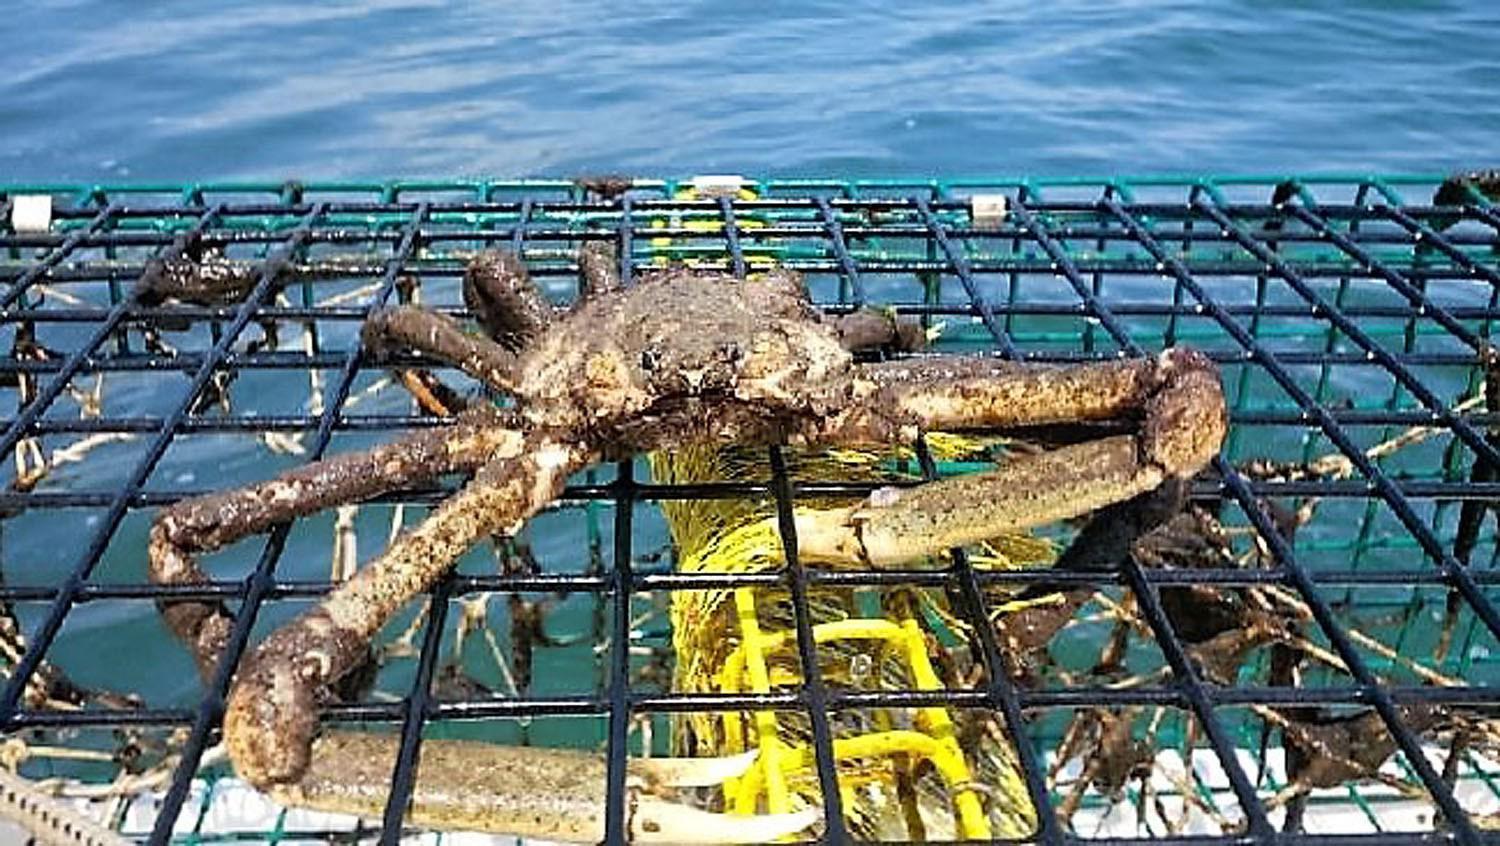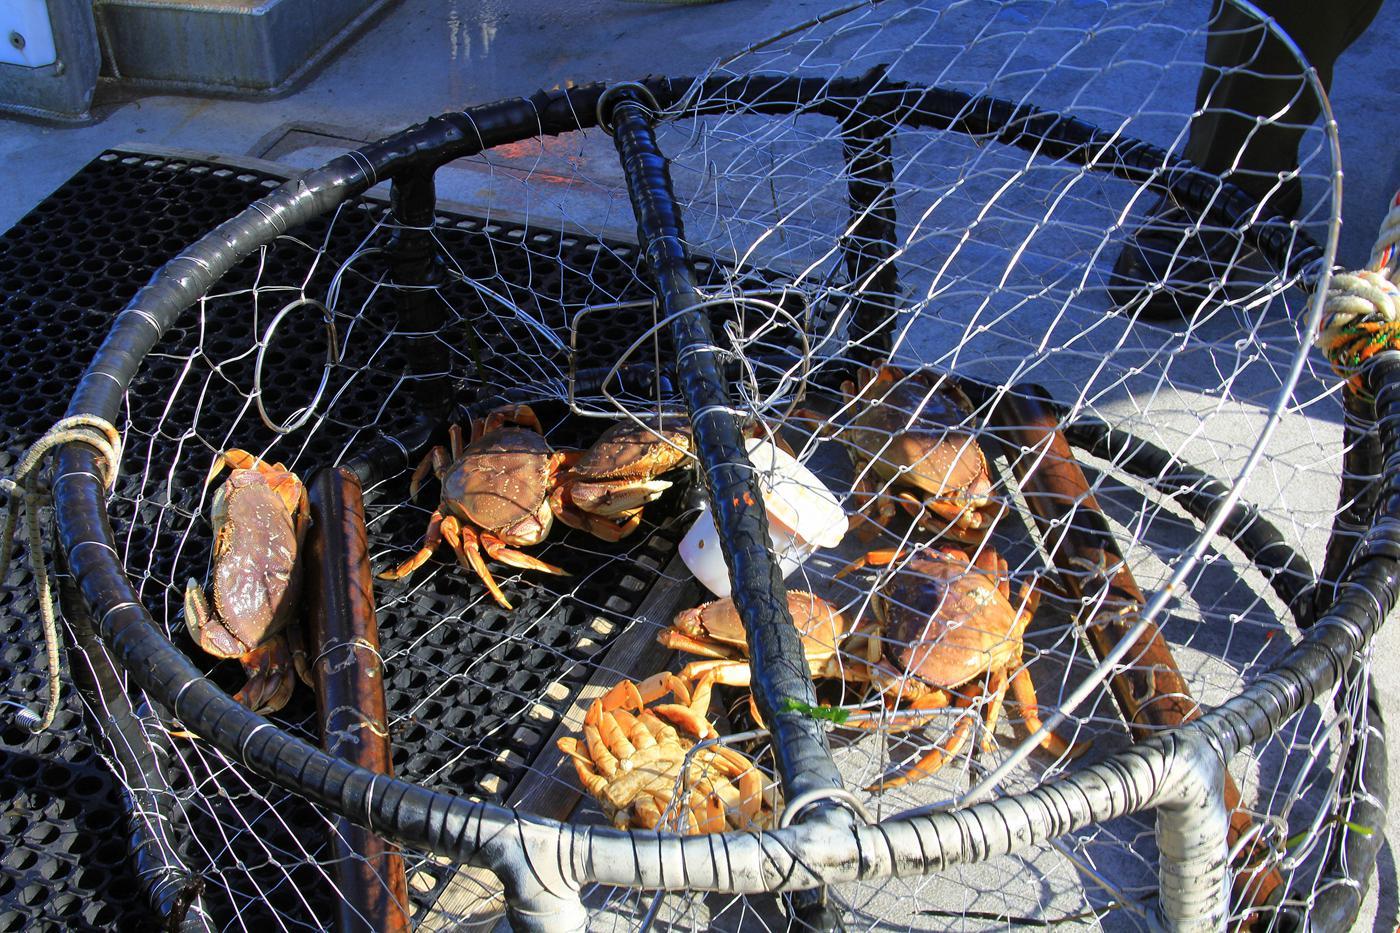The first image is the image on the left, the second image is the image on the right. Considering the images on both sides, is "All of the baskets holding the crabs are circular." valid? Answer yes or no. No. The first image is the image on the left, the second image is the image on the right. Examine the images to the left and right. Is the description "All the crabs are in cages." accurate? Answer yes or no. No. 